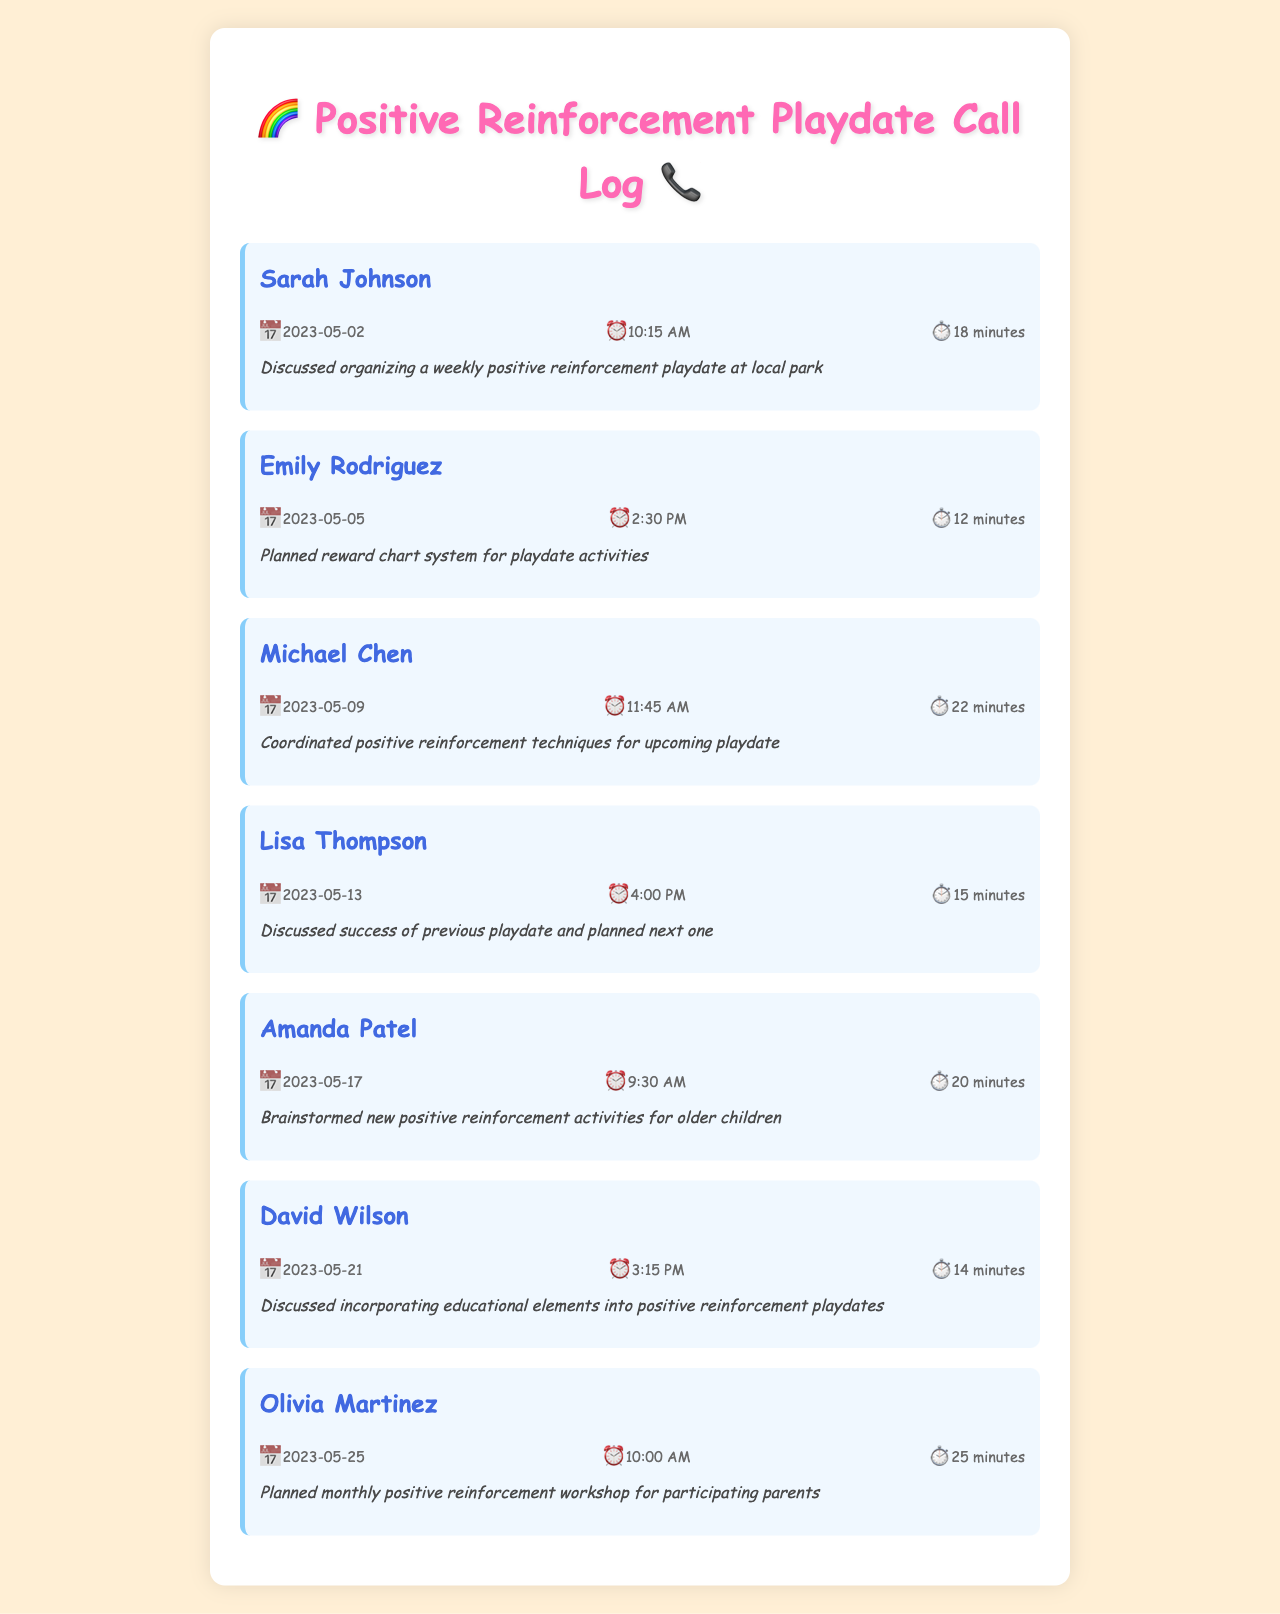What date did I call Sarah Johnson? The document provides the date of the call to Sarah Johnson as 2023-05-02.
Answer: 2023-05-02 How long was the call with Michael Chen? The document states that the call with Michael Chen lasted for 22 minutes.
Answer: 22 minutes What was discussed during the call with Emily Rodriguez? The notes indicate that a reward chart system for playdate activities was planned during the call with Emily Rodriguez.
Answer: Planned reward chart system for playdate activities Who is the last person I called regarding playdates? The last call recorded in the document is with Olivia Martinez.
Answer: Olivia Martinez What type of reinforcement activities were brainstormed with Amanda Patel? The notes specify that new positive reinforcement activities for older children were brainstormed with Amanda Patel.
Answer: New positive reinforcement activities for older children How many minutes long was the call with Lisa Thompson? The document states that the call with Lisa Thompson lasted for 15 minutes.
Answer: 15 minutes What was the purpose of the call on 2023-05-25? The call on this date involved planning a monthly positive reinforcement workshop for participating parents.
Answer: Planned monthly positive reinforcement workshop for participating parents Which parent discussed the success of a previous playdate? Lisa Thompson discussed the success of the previous playdate during her call.
Answer: Lisa Thompson 